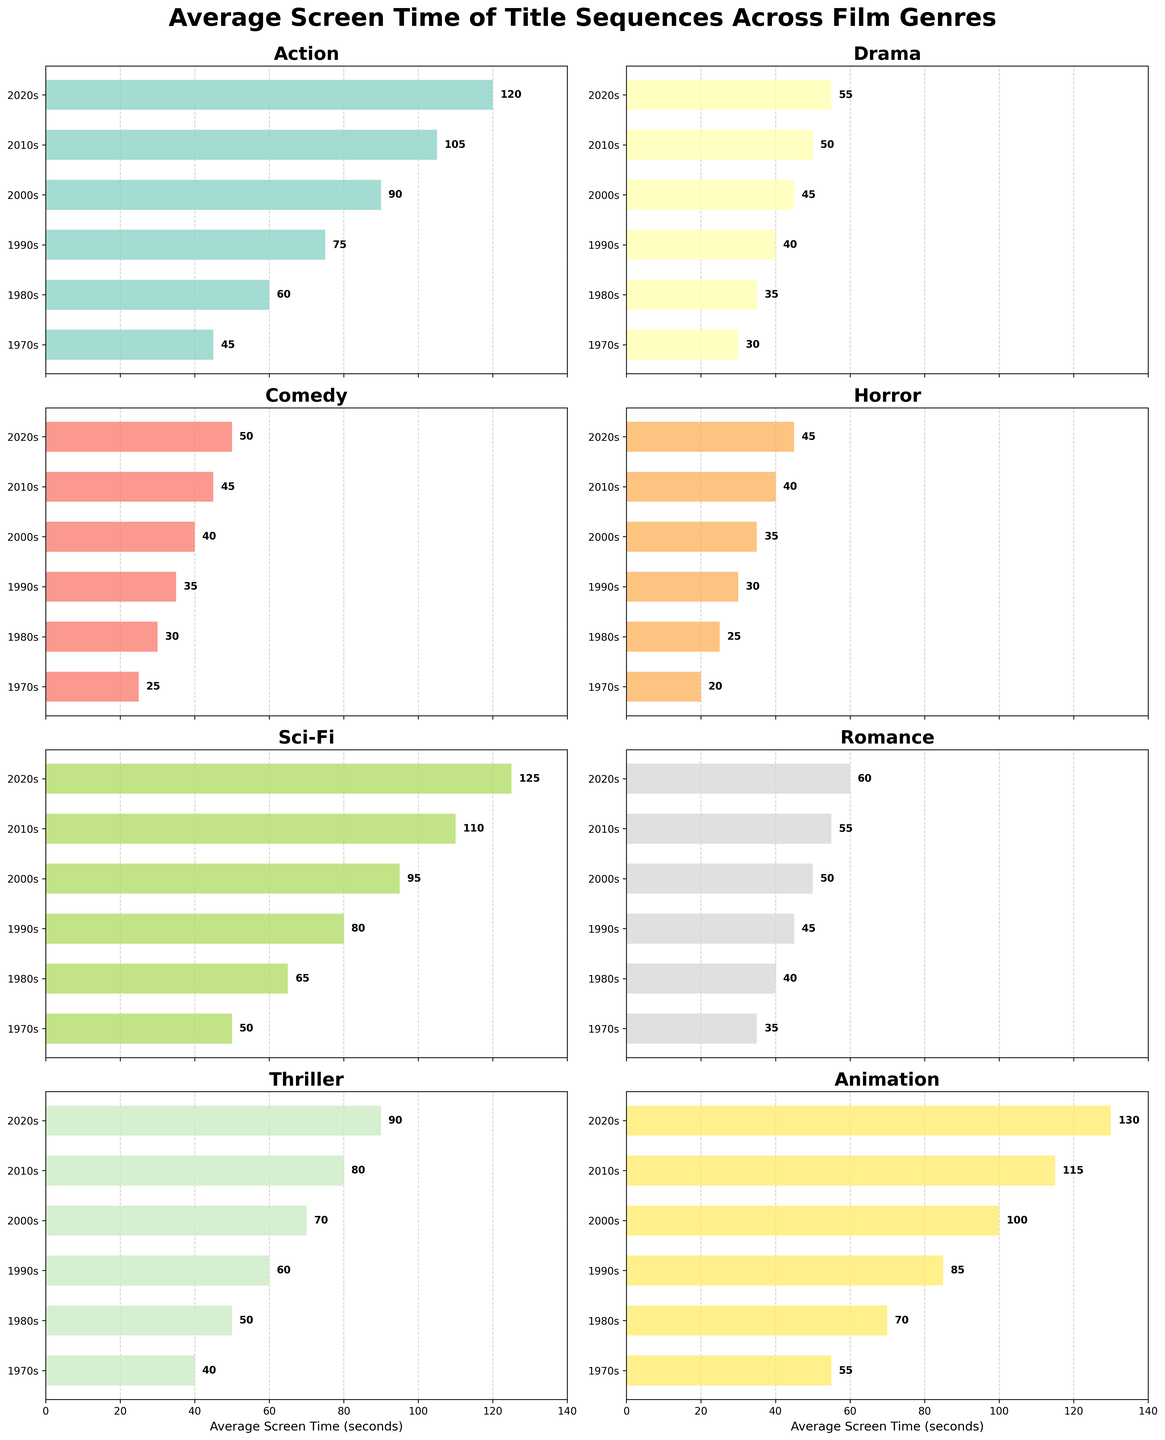What's the average screen time for Sci-Fi movies in the 2010s? Look at the Sci-Fi subplot and find the bar representing the 2010s. The value is labeled at the end of the bar.
Answer: 110 Which genre had the longest average screen time in the 2020s? Review all the subplots for the year 2020s and identify the tallest bar. Animation genre has the highest bar in the 2020s.
Answer: Animation How did the average screen time for Action movies change from the 1970s to the 2020s? Look at the Action subplot and subtract the 1970s value from the 2020s value. 120 (2020s) - 45 (1970s) = 75 seconds.
Answer: Increased by 75 seconds Among Comedy, Drama, and Horror genres, which had the smallest increase in screen time from the 1980s to the 2000s? Find the increase for each genre: 
Comedy: 40 (2000s) - 30 (1980s) = 10,
Drama: 45 (2000s) - 35 (1980s) = 10,
Horror: 35 (2000s) - 25 (1980s) = 10. 
All three genres have the same increase.
Answer: Same increase Compare the average screen time for Animation and Thriller genres in the 2010s. Which is higher and by how much? Look at both Animation and Thriller subplots in the 2010s. 
Animation: 115,
Thriller: 80.
Animation is higher: 115 - 80 = 35 seconds.
Answer: Animation by 35 seconds Which genre has shown the most consistent increase in screen time over the decades? Examine each subplot for a smooth and linear upward trend. Drama shows the most consistent increase from 30 in the 1970s to 55 in the 2020s.
Answer: Drama What is the range of average screen time for Romance movies from the 1970s to the 2020s? Look at the Romance subplot, noting the minimum and maximum values. 
Max: 60 (2020s),
Min: 35 (1970s).
Range: 60 - 35 = 25 seconds.
Answer: 25 seconds Which decade saw the largest jump in average screen time for Sci-Fi movies? Evaluate the Sci-Fi subplot for the largest difference between consecutive decades. The jump from the 2000s (95) to the 2010s (110) is 15 seconds, which is the highest.
Answer: 2000s to 2010s What conclusions can be drawn from the average screen time trends for Horror and Animation genres over the decades? Review the trends in both subplots. Animation shows a consistent and sharp increase, suggesting growing importance. Horror shows a steady but more modest increase, indicating moderate growth in importance.
Answer: Animation importance growing, Horror moderate growth 